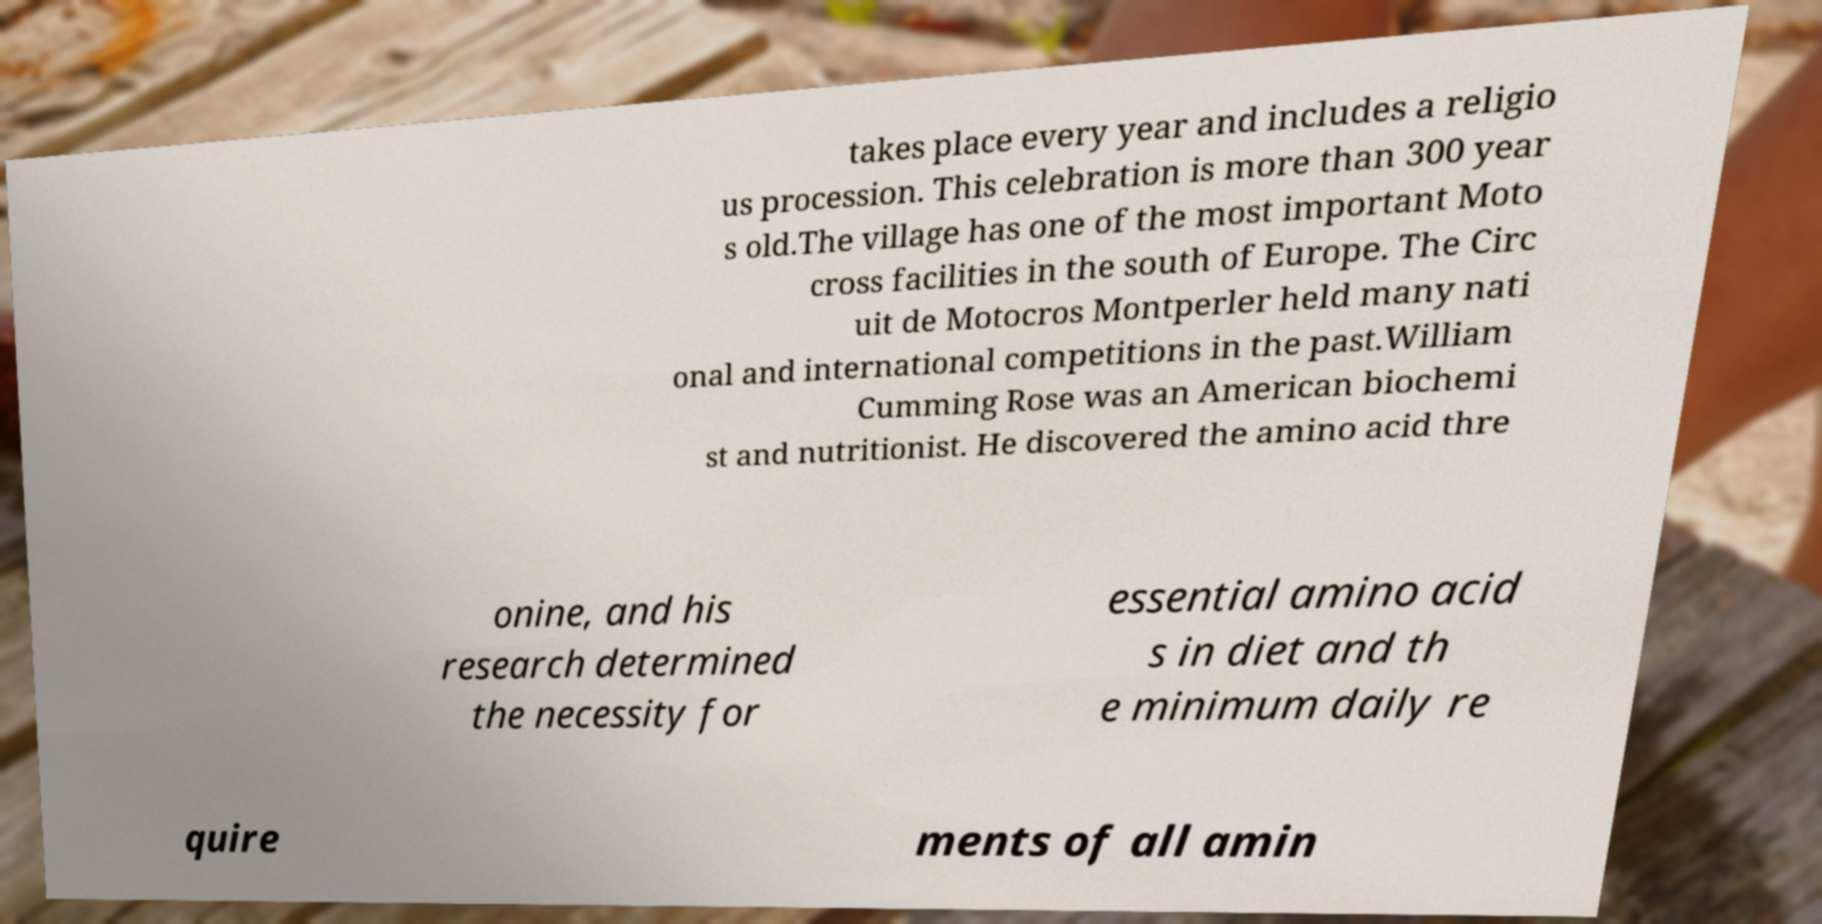Can you read and provide the text displayed in the image?This photo seems to have some interesting text. Can you extract and type it out for me? takes place every year and includes a religio us procession. This celebration is more than 300 year s old.The village has one of the most important Moto cross facilities in the south of Europe. The Circ uit de Motocros Montperler held many nati onal and international competitions in the past.William Cumming Rose was an American biochemi st and nutritionist. He discovered the amino acid thre onine, and his research determined the necessity for essential amino acid s in diet and th e minimum daily re quire ments of all amin 